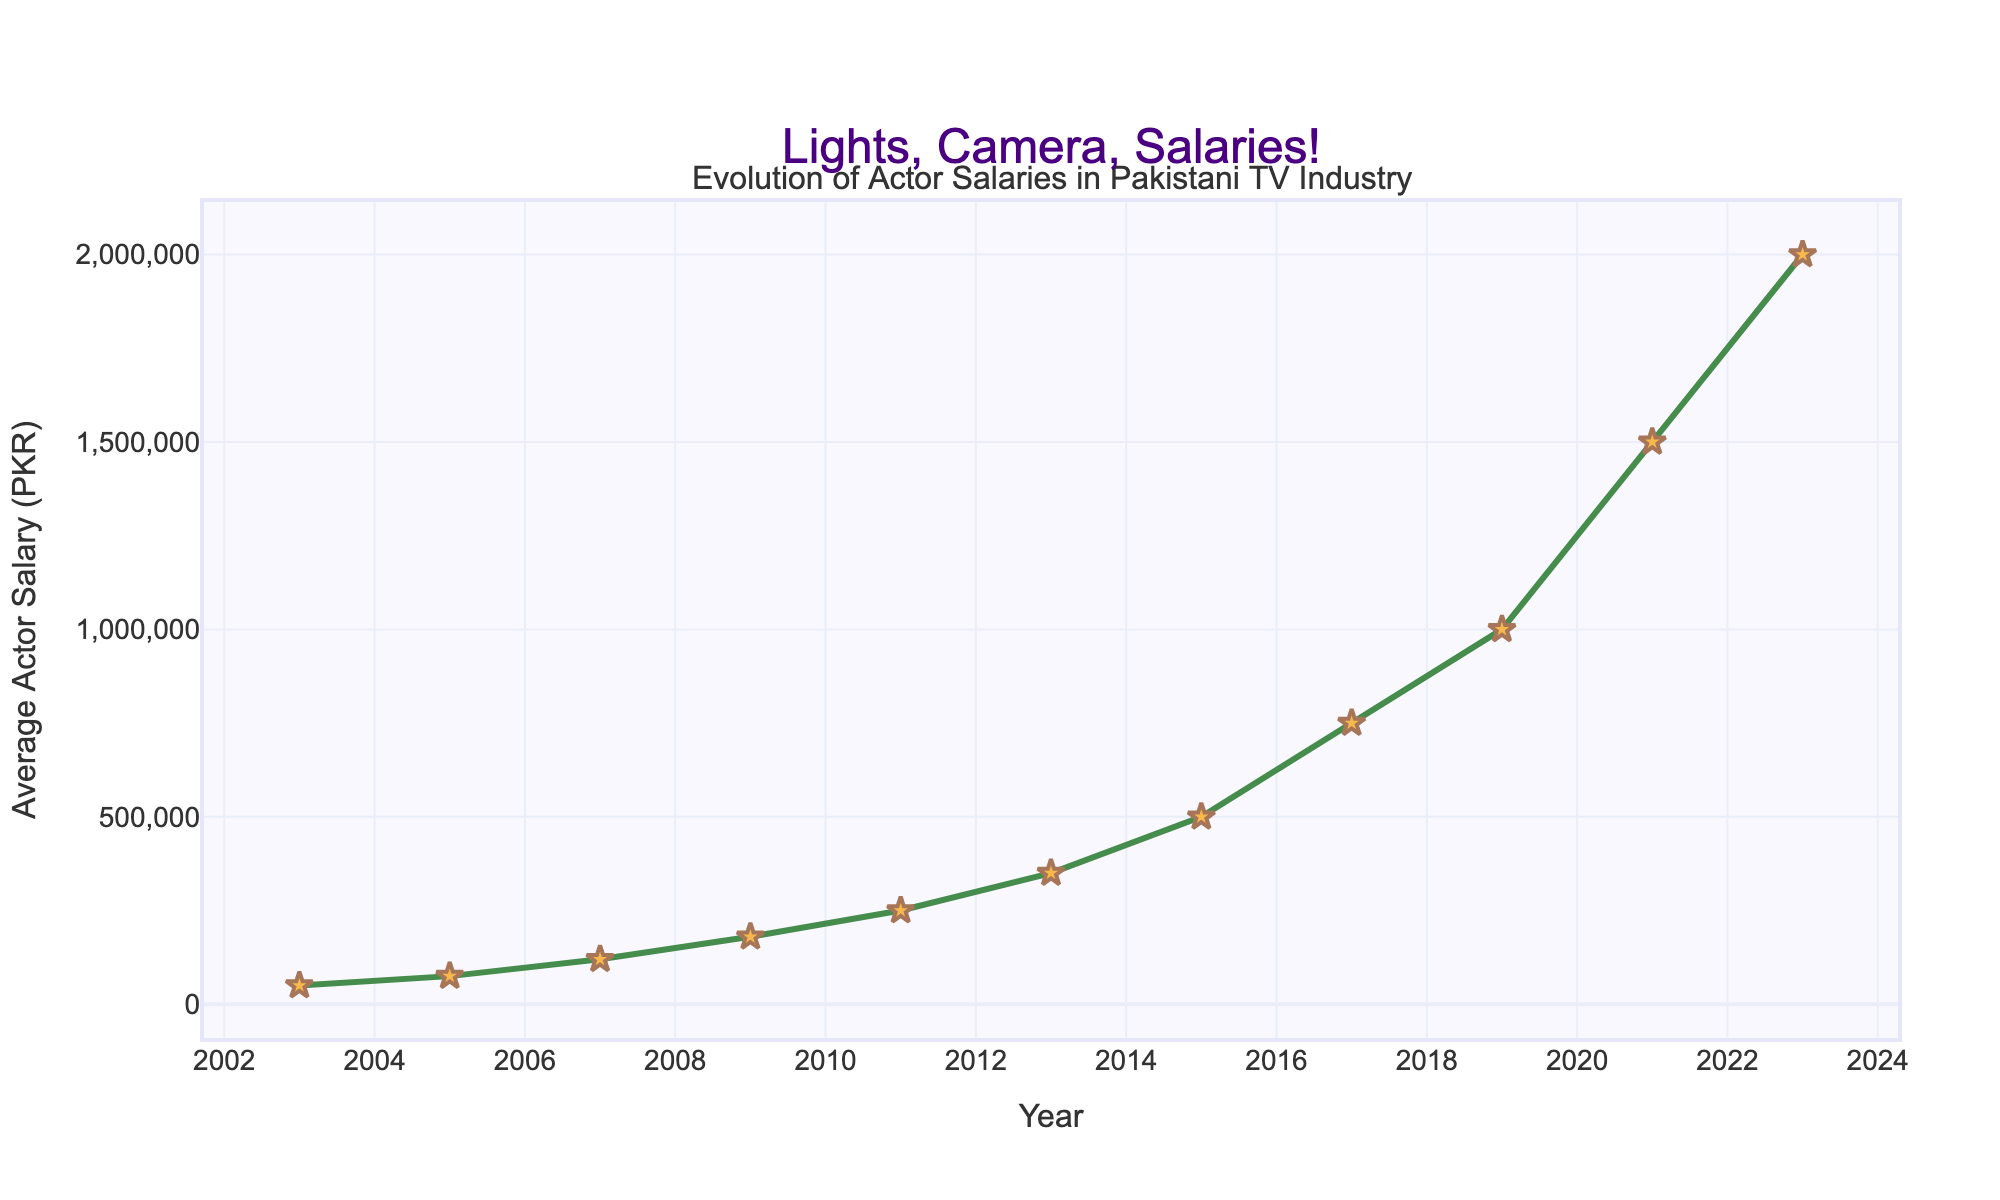What was the average actor salary in 2009? From the figure, locate the year 2009 on the x-axis and then find the corresponding value on the y-axis. The label shows 180,000 PKR.
Answer: 180,000 PKR Between which consecutive years did the actor salaries increase the most? Observe the line chart to find the steepest upward slope between consecutive years. The steepest increase is between 2021 and 2023.
Answer: 2021-2023 How much did the average actor salary increase from 2003 to 2023? Find the average salaries for 2003 (50,000 PKR) and 2023 (2,000,000 PKR). Subtract the 2003 value from the 2023 value (2,000,000 - 50,000).
Answer: 1,950,000 PKR What was the percentage increase in average actor salary from 2015 to 2019? Identify the salaries in 2015 (500,000 PKR) and 2019 (1,000,000 PKR). Calculate the increase ((1,000,000 - 500,000) / 500,000 * 100%).
Answer: 100% Which year had the smallest increase in average actor salary compared to the previous year? Compare the increases in salary between each consecutive pair of years. The smallest increase is between 2007 (120,000 PKR) and 2009 (180,000 PKR), which is 60,000 PKR.
Answer: 2007-2009 What was the average actor salary in 2011, and how does it compare to 2013? Find the salaries for 2011 (250,000 PKR) and 2013 (350,000 PKR) on the y-axis. Compare these values to see the difference (350,000 - 250,000).
Answer: 2011 was 250,000 PKR, and the increase by 2013 was 100,000 PKR What is the overall trend in actor salaries over the last 20 years? Look at the general flow of the line in the chart; actor salaries consistently increased over the years from 2003 to 2023.
Answer: Upwards trend How many times did the average actor salary double over these 20 years? Starting from 50,000 PKR in 2003, the salary doubles multiple times up to 2,000,000 PKR in 2023 (50,000 -> 100,000 -> 200,000 -> 400,000 -> 800,000 -> 1,600,000). Count these steps.
Answer: Five times 